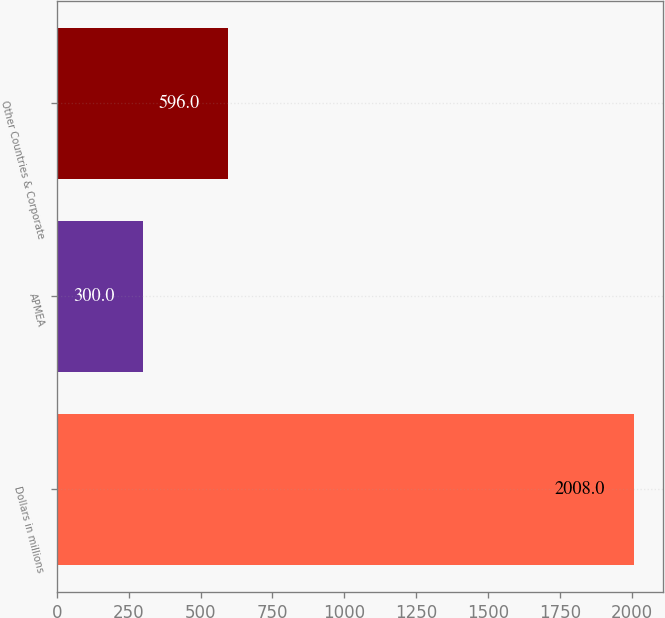Convert chart. <chart><loc_0><loc_0><loc_500><loc_500><bar_chart><fcel>Dollars in millions<fcel>APMEA<fcel>Other Countries & Corporate<nl><fcel>2008<fcel>300<fcel>596<nl></chart> 